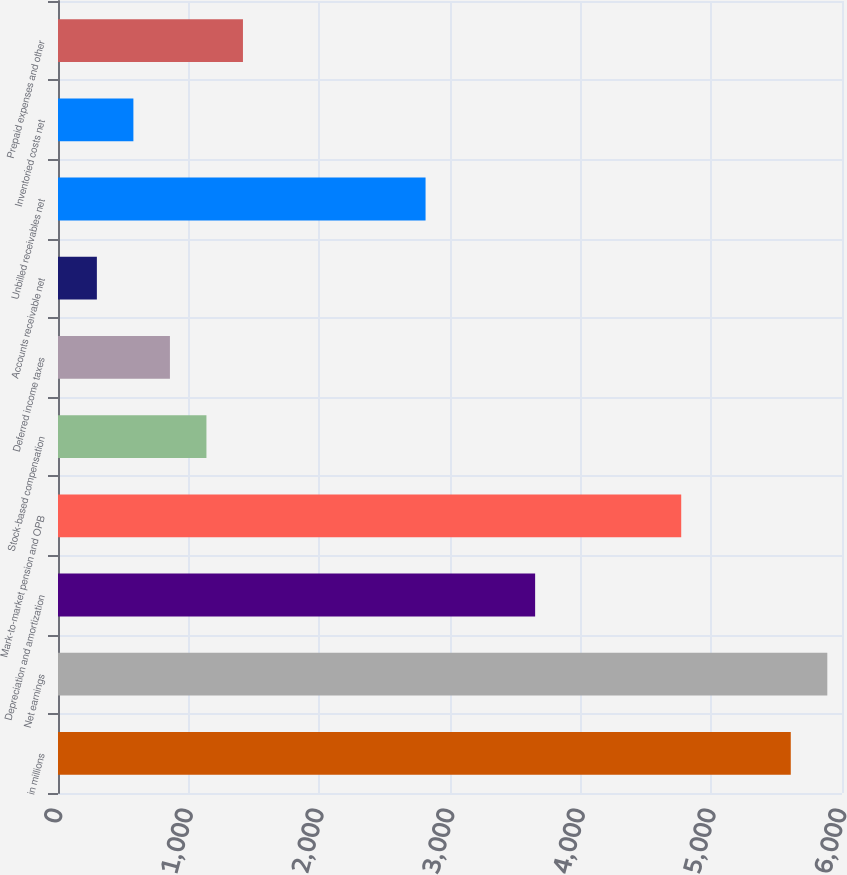Convert chart. <chart><loc_0><loc_0><loc_500><loc_500><bar_chart><fcel>in millions<fcel>Net earnings<fcel>Depreciation and amortization<fcel>Mark-to-market pension and OPB<fcel>Stock-based compensation<fcel>Deferred income taxes<fcel>Accounts receivable net<fcel>Unbilled receivables net<fcel>Inventoried costs net<fcel>Prepaid expenses and other<nl><fcel>5608<fcel>5887.5<fcel>3651.5<fcel>4769.5<fcel>1136<fcel>856.5<fcel>297.5<fcel>2813<fcel>577<fcel>1415.5<nl></chart> 